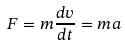<formula> <loc_0><loc_0><loc_500><loc_500>F = m \frac { d v } { d t } = m a</formula> 